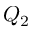Convert formula to latex. <formula><loc_0><loc_0><loc_500><loc_500>Q _ { 2 }</formula> 